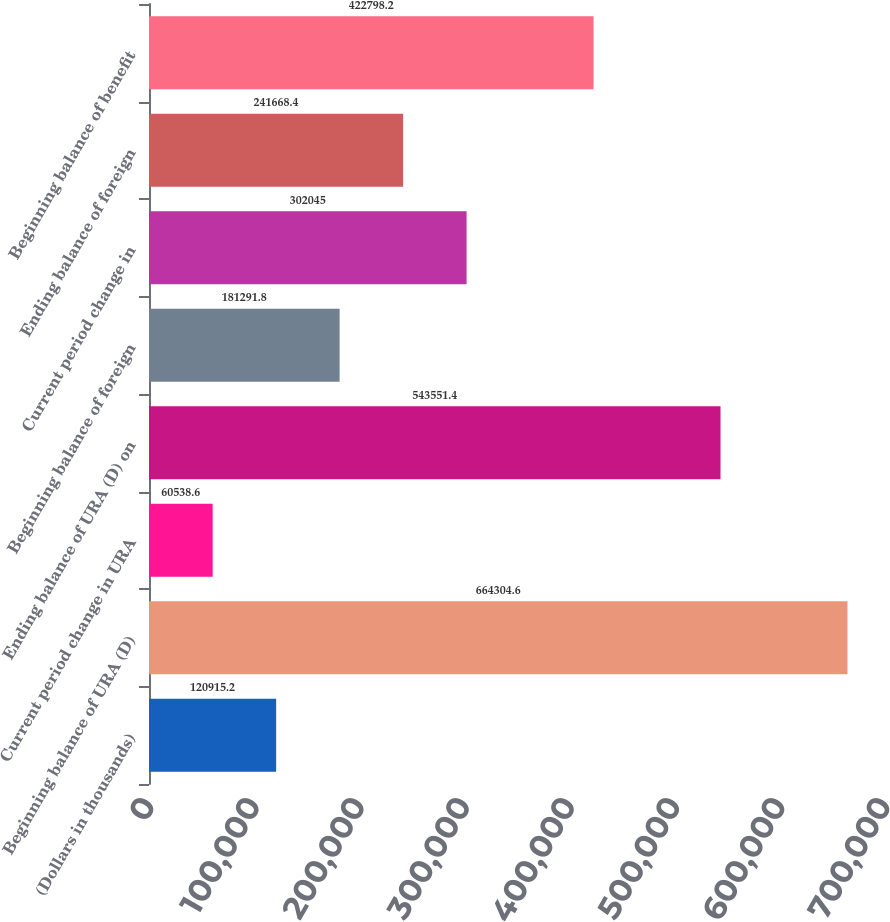Convert chart to OTSL. <chart><loc_0><loc_0><loc_500><loc_500><bar_chart><fcel>(Dollars in thousands)<fcel>Beginning balance of URA (D)<fcel>Current period change in URA<fcel>Ending balance of URA (D) on<fcel>Beginning balance of foreign<fcel>Current period change in<fcel>Ending balance of foreign<fcel>Beginning balance of benefit<nl><fcel>120915<fcel>664305<fcel>60538.6<fcel>543551<fcel>181292<fcel>302045<fcel>241668<fcel>422798<nl></chart> 